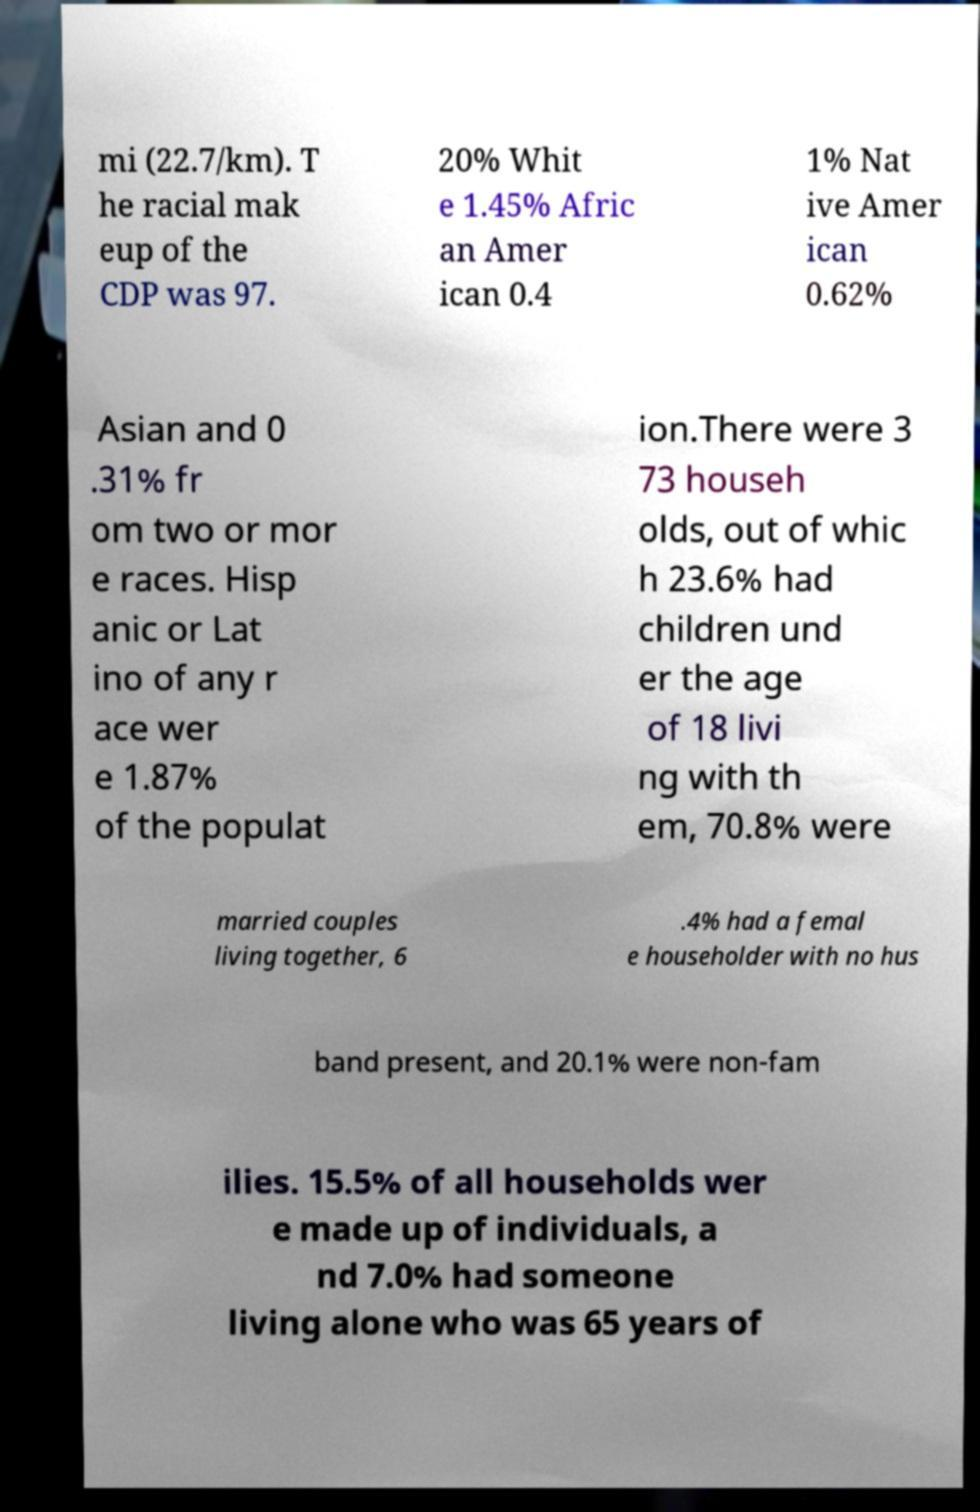For documentation purposes, I need the text within this image transcribed. Could you provide that? mi (22.7/km). T he racial mak eup of the CDP was 97. 20% Whit e 1.45% Afric an Amer ican 0.4 1% Nat ive Amer ican 0.62% Asian and 0 .31% fr om two or mor e races. Hisp anic or Lat ino of any r ace wer e 1.87% of the populat ion.There were 3 73 househ olds, out of whic h 23.6% had children und er the age of 18 livi ng with th em, 70.8% were married couples living together, 6 .4% had a femal e householder with no hus band present, and 20.1% were non-fam ilies. 15.5% of all households wer e made up of individuals, a nd 7.0% had someone living alone who was 65 years of 